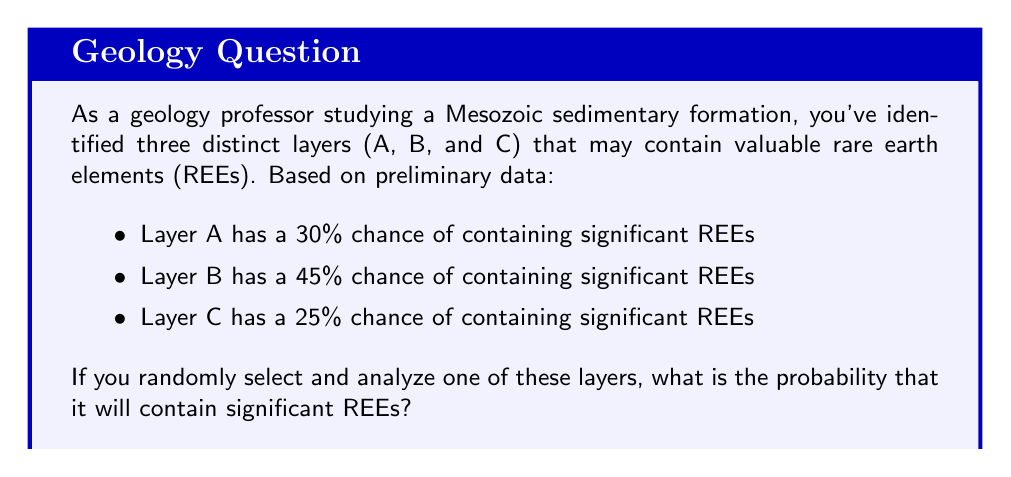Show me your answer to this math problem. To solve this problem, we need to consider the principle of total probability. Since we are randomly selecting one layer, each layer has an equal chance (1/3) of being chosen. We then multiply this probability by the chance of each layer containing significant REEs and sum these probabilities.

Let's break it down step-by-step:

1) Probability of selecting Layer A and finding REEs:
   $P(A) \times P(\text{REEs in A}) = \frac{1}{3} \times 0.30 = 0.10$

2) Probability of selecting Layer B and finding REEs:
   $P(B) \times P(\text{REEs in B}) = \frac{1}{3} \times 0.45 = 0.15$

3) Probability of selecting Layer C and finding REEs:
   $P(C) \times P(\text{REEs in C}) = \frac{1}{3} \times 0.25 = 0.0833$ (rounded to 4 decimal places)

4) Total probability:
   $P(\text{REEs}) = P(A) \times P(\text{REEs in A}) + P(B) \times P(\text{REEs in B}) + P(C) \times P(\text{REEs in C})$
   
   $P(\text{REEs}) = 0.10 + 0.15 + 0.0833 = 0.3333$

Therefore, the probability of randomly selecting a layer containing significant REEs is approximately 0.3333 or 33.33%.
Answer: The probability is approximately 0.3333 or 33.33%. 